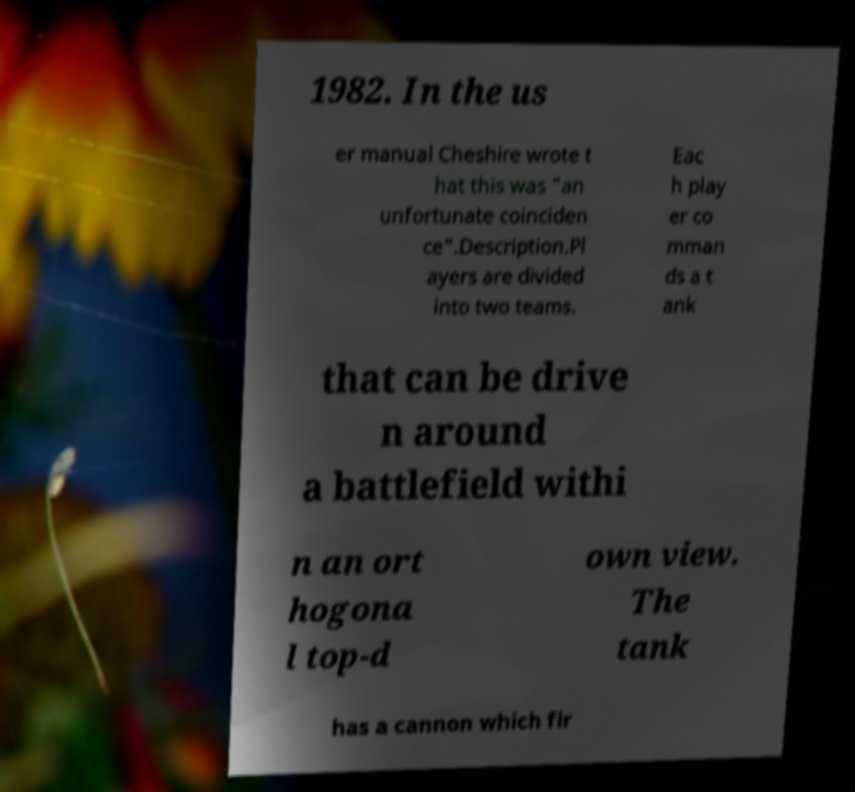Could you extract and type out the text from this image? 1982. In the us er manual Cheshire wrote t hat this was "an unfortunate coinciden ce".Description.Pl ayers are divided into two teams. Eac h play er co mman ds a t ank that can be drive n around a battlefield withi n an ort hogona l top-d own view. The tank has a cannon which fir 